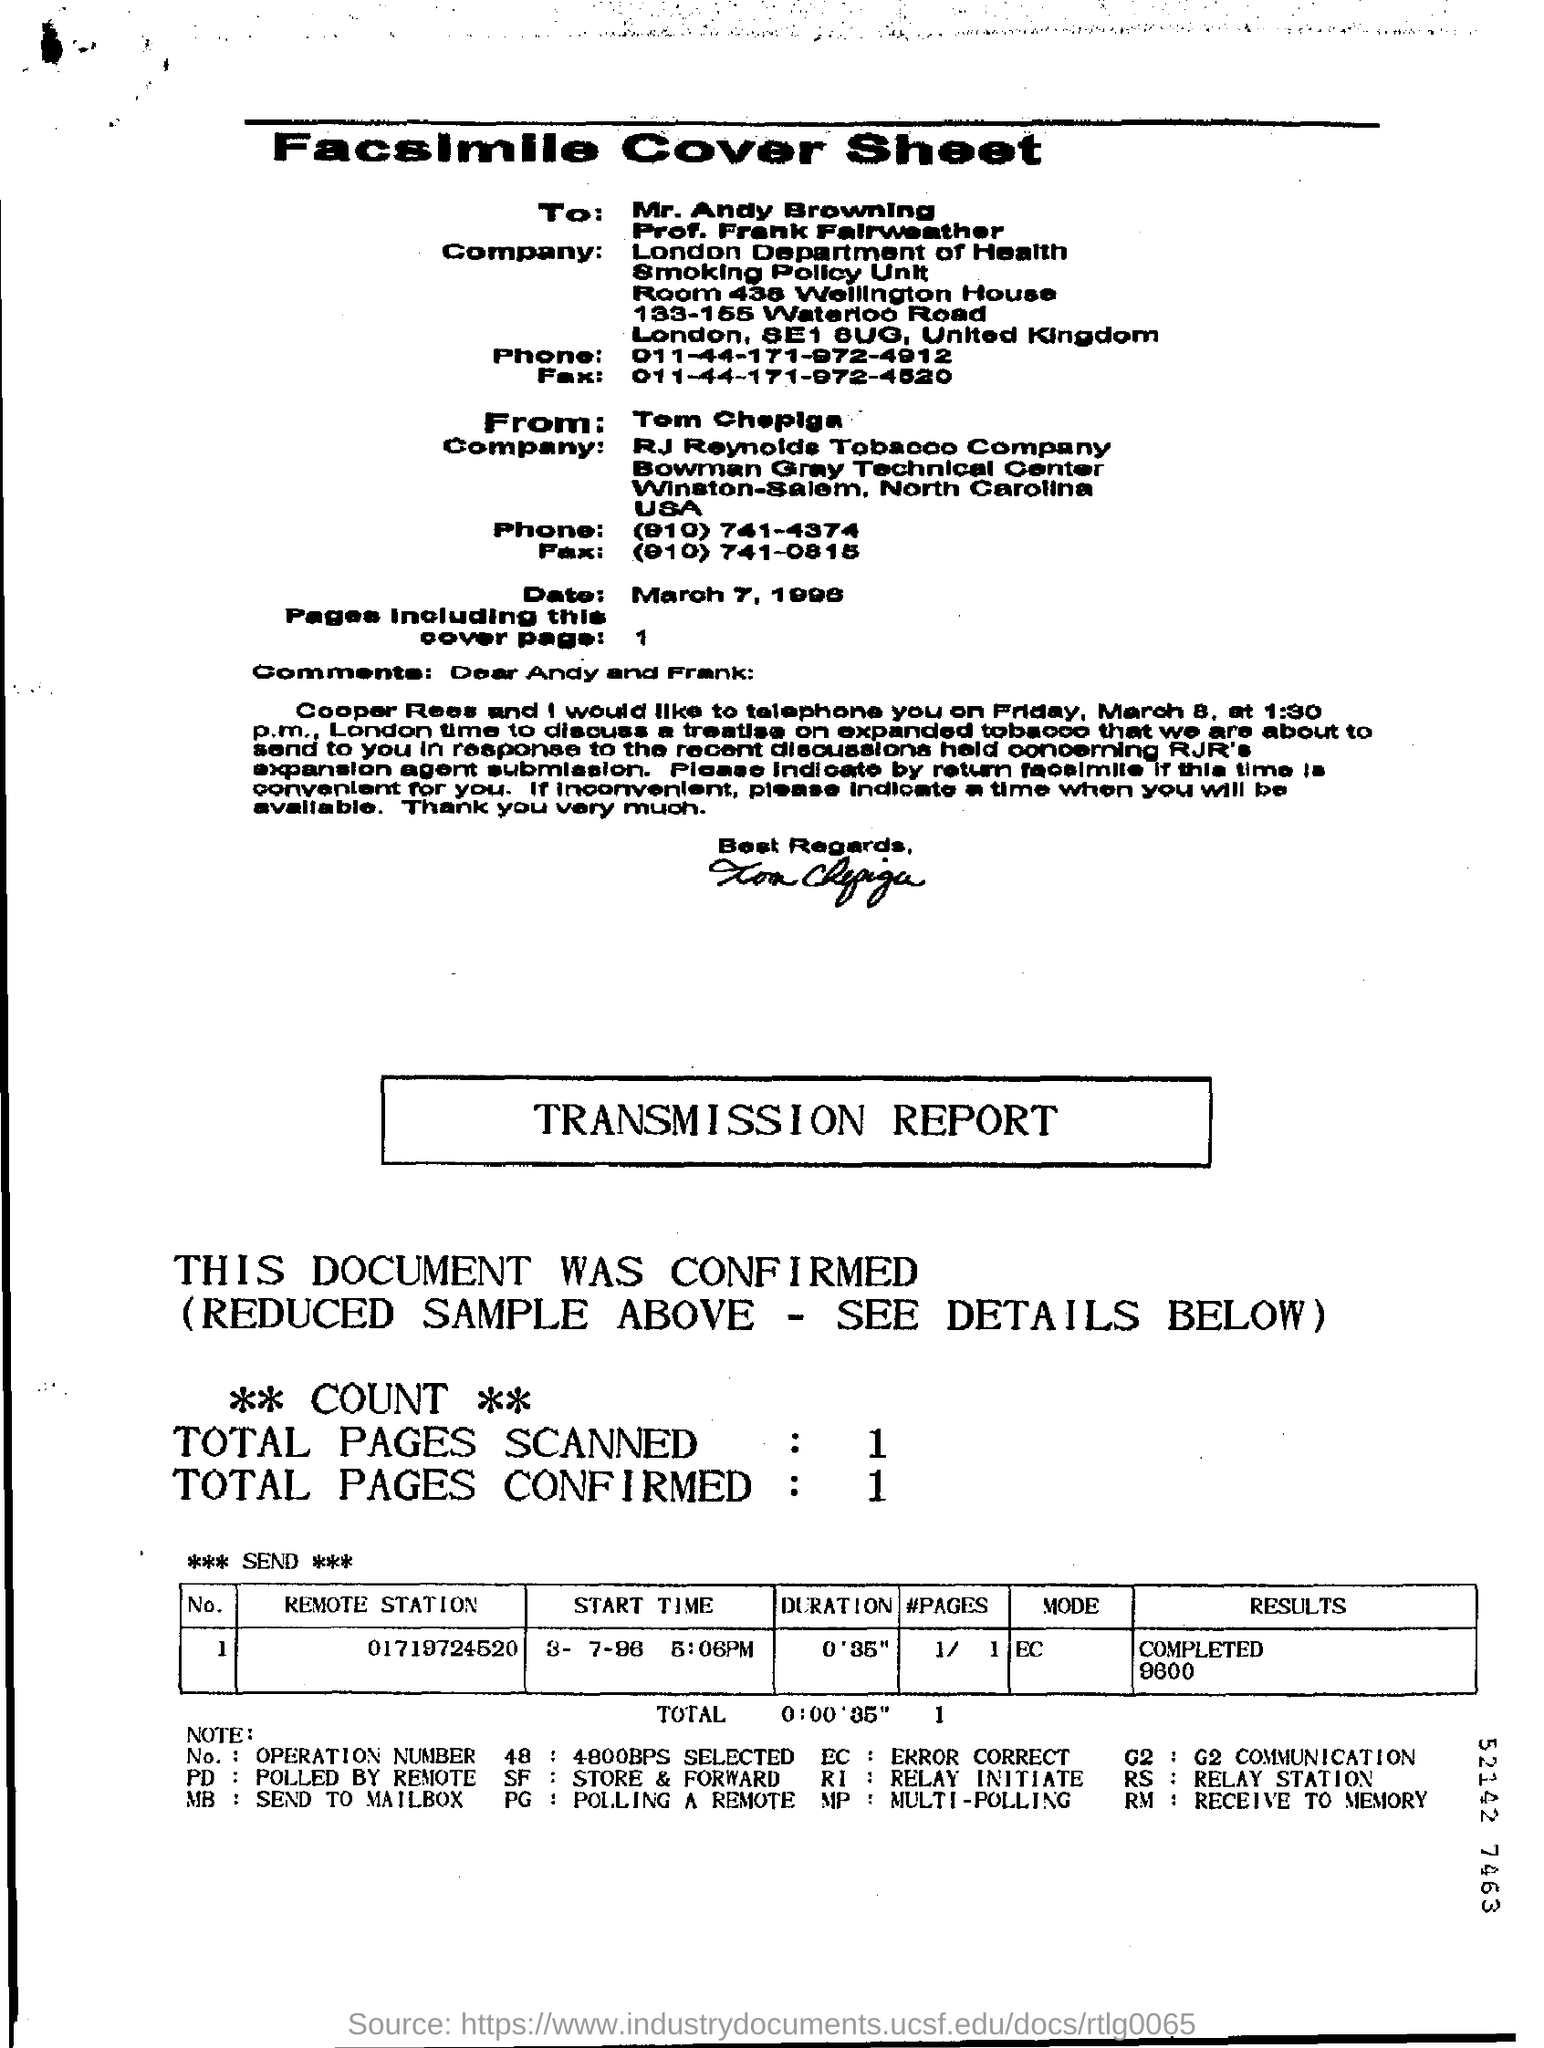Give some essential details in this illustration. I, [name], declare that "RM" stands for "Receive to Memory," a process where data is transferred from one device to another and stored in the recipient's memory. 